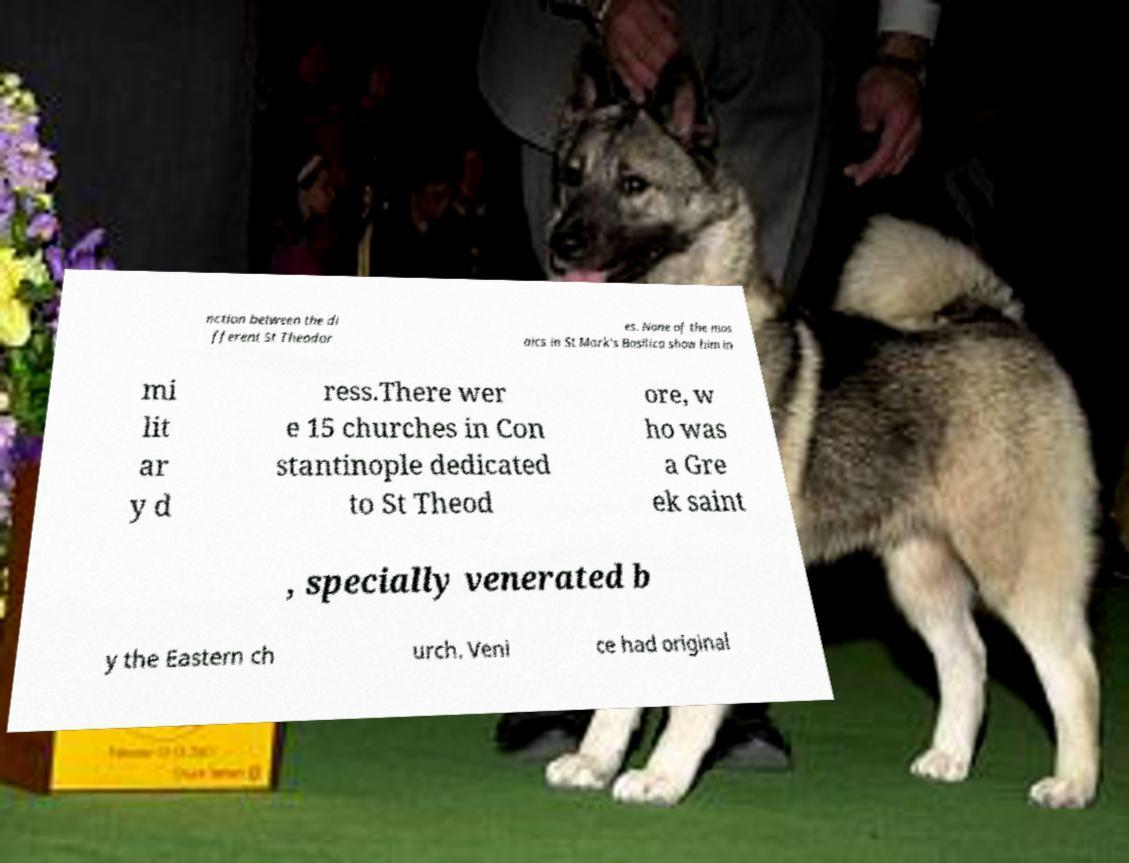Can you read and provide the text displayed in the image?This photo seems to have some interesting text. Can you extract and type it out for me? nction between the di fferent St Theodor es. None of the mos aics in St Mark's Basilica show him in mi lit ar y d ress.There wer e 15 churches in Con stantinople dedicated to St Theod ore, w ho was a Gre ek saint , specially venerated b y the Eastern ch urch. Veni ce had original 